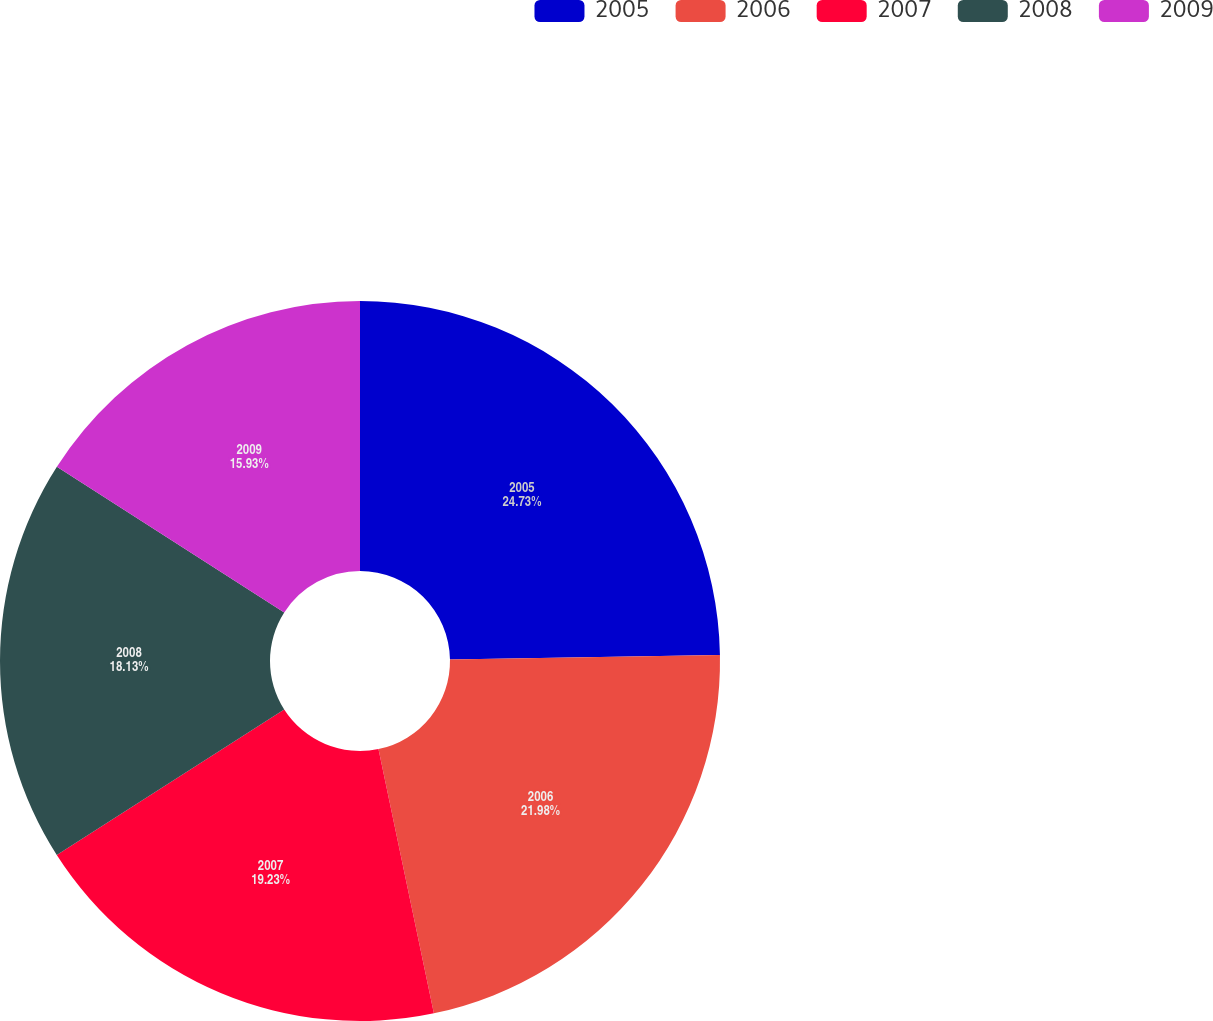Convert chart. <chart><loc_0><loc_0><loc_500><loc_500><pie_chart><fcel>2005<fcel>2006<fcel>2007<fcel>2008<fcel>2009<nl><fcel>24.73%<fcel>21.98%<fcel>19.23%<fcel>18.13%<fcel>15.93%<nl></chart> 